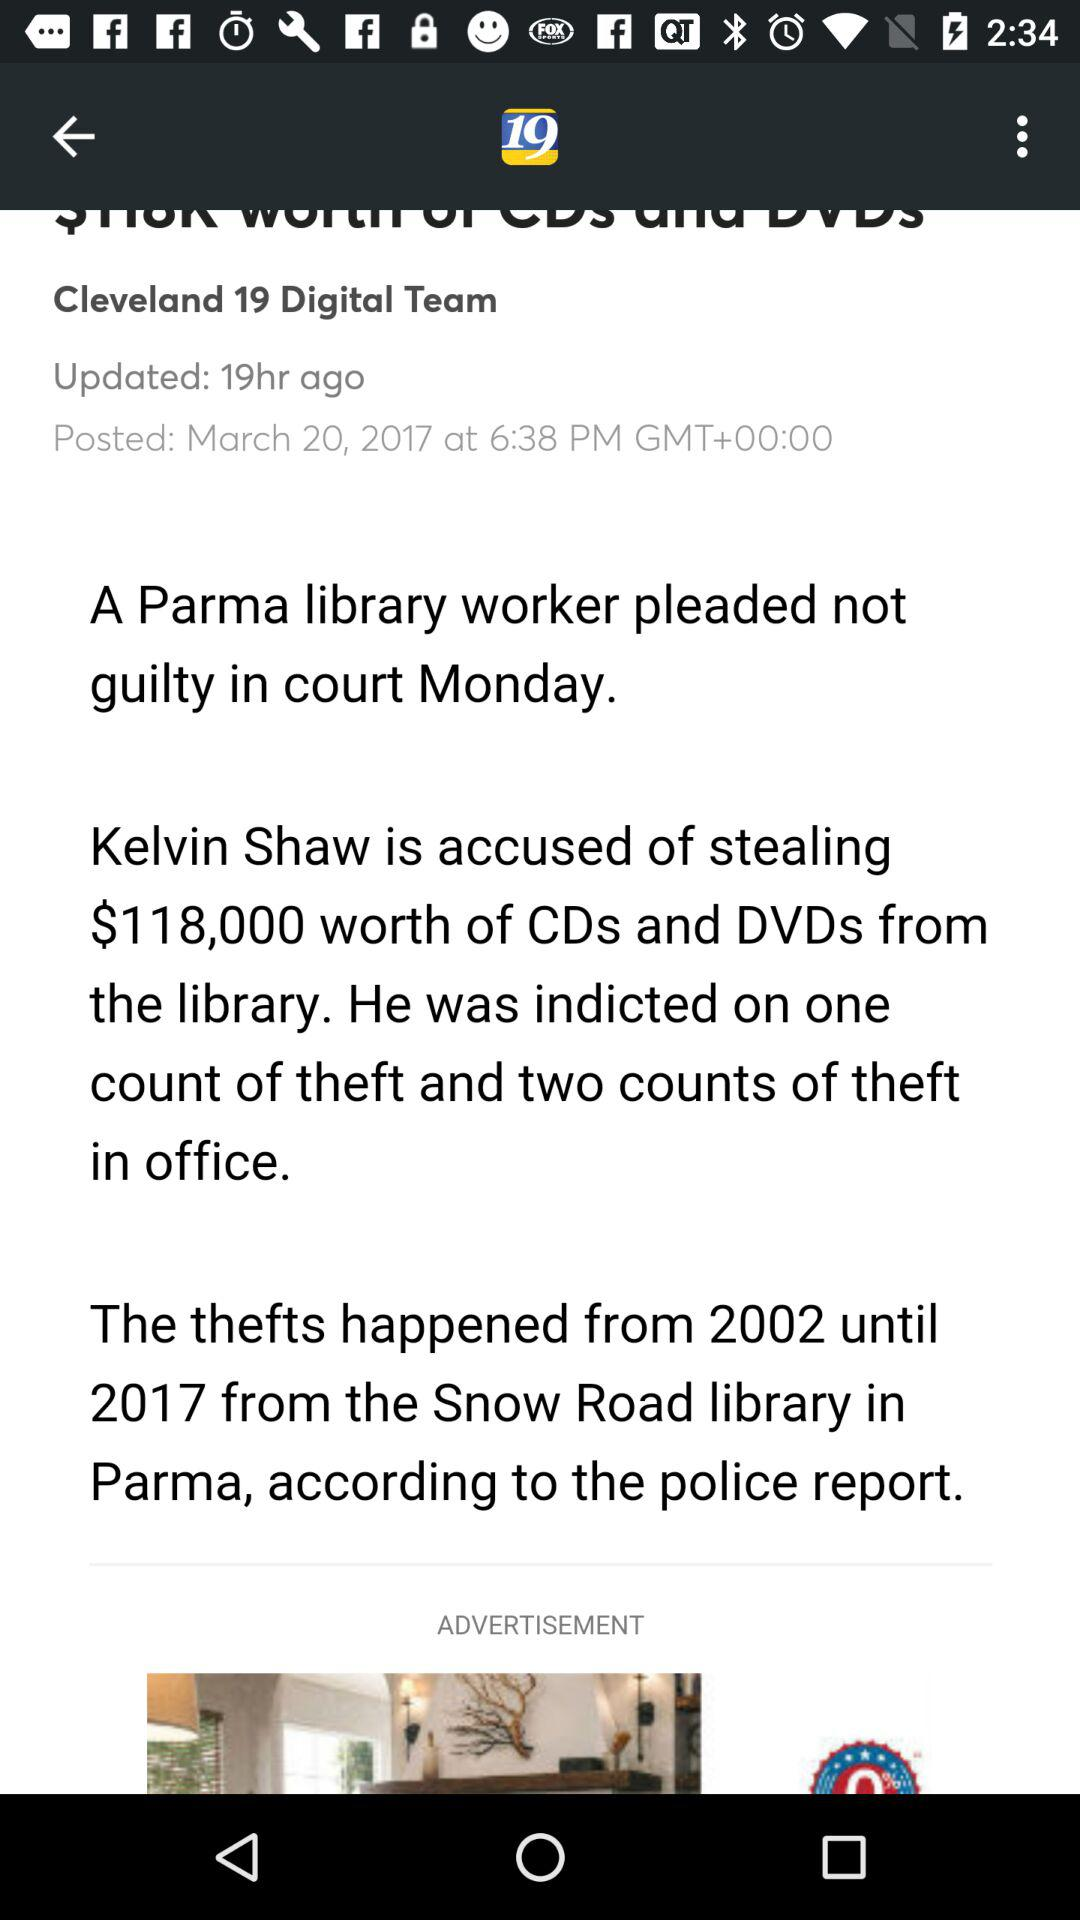When was the article updated? The article was updated 19 hours ago. 